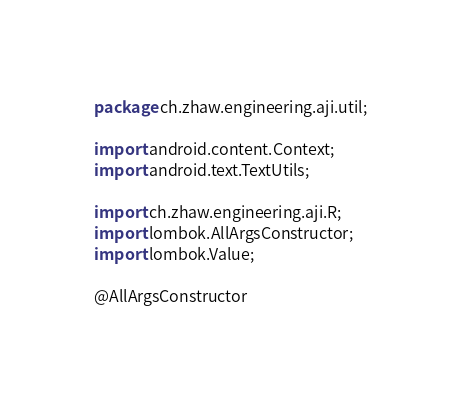<code> <loc_0><loc_0><loc_500><loc_500><_Java_>package ch.zhaw.engineering.aji.util;

import android.content.Context;
import android.text.TextUtils;

import ch.zhaw.engineering.aji.R;
import lombok.AllArgsConstructor;
import lombok.Value;

@AllArgsConstructor</code> 